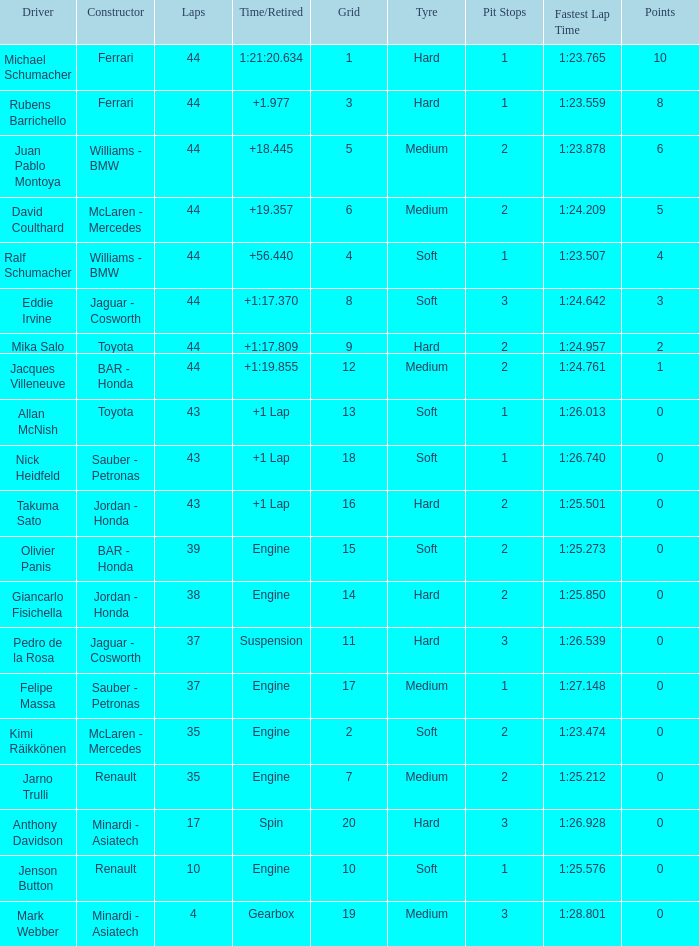What was the fewest laps for somone who finished +18.445? 44.0. Could you help me parse every detail presented in this table? {'header': ['Driver', 'Constructor', 'Laps', 'Time/Retired', 'Grid', 'Tyre', 'Pit Stops', 'Fastest Lap Time', 'Points'], 'rows': [['Michael Schumacher', 'Ferrari', '44', '1:21:20.634', '1', 'Hard', '1', '1:23.765', '10'], ['Rubens Barrichello', 'Ferrari', '44', '+1.977', '3', 'Hard', '1', '1:23.559', '8'], ['Juan Pablo Montoya', 'Williams - BMW', '44', '+18.445', '5', 'Medium', '2', '1:23.878', '6'], ['David Coulthard', 'McLaren - Mercedes', '44', '+19.357', '6', 'Medium', '2', '1:24.209', '5'], ['Ralf Schumacher', 'Williams - BMW', '44', '+56.440', '4', 'Soft', '1', '1:23.507', '4'], ['Eddie Irvine', 'Jaguar - Cosworth', '44', '+1:17.370', '8', 'Soft', '3', '1:24.642', '3'], ['Mika Salo', 'Toyota', '44', '+1:17.809', '9', 'Hard', '2', '1:24.957', '2'], ['Jacques Villeneuve', 'BAR - Honda', '44', '+1:19.855', '12', 'Medium', '2', '1:24.761', '1'], ['Allan McNish', 'Toyota', '43', '+1 Lap', '13', 'Soft', '1', '1:26.013', '0'], ['Nick Heidfeld', 'Sauber - Petronas', '43', '+1 Lap', '18', 'Soft', '1', '1:26.740', '0'], ['Takuma Sato', 'Jordan - Honda', '43', '+1 Lap', '16', 'Hard', '2', '1:25.501', '0'], ['Olivier Panis', 'BAR - Honda', '39', 'Engine', '15', 'Soft', '2', '1:25.273', '0'], ['Giancarlo Fisichella', 'Jordan - Honda', '38', 'Engine', '14', 'Hard', '2', '1:25.850', '0'], ['Pedro de la Rosa', 'Jaguar - Cosworth', '37', 'Suspension', '11', 'Hard', '3', '1:26.539', '0'], ['Felipe Massa', 'Sauber - Petronas', '37', 'Engine', '17', 'Medium', '1', '1:27.148', '0'], ['Kimi Räikkönen', 'McLaren - Mercedes', '35', 'Engine', '2', 'Soft', '2', '1:23.474', '0'], ['Jarno Trulli', 'Renault', '35', 'Engine', '7', 'Medium', '2', '1:25.212', '0'], ['Anthony Davidson', 'Minardi - Asiatech', '17', 'Spin', '20', 'Hard', '3', '1:26.928', '0'], ['Jenson Button', 'Renault', '10', 'Engine', '10', 'Soft', '1', '1:25.576', '0'], ['Mark Webber', 'Minardi - Asiatech', '4', 'Gearbox', '19', 'Medium', '3', '1:28.801', '0']]} 